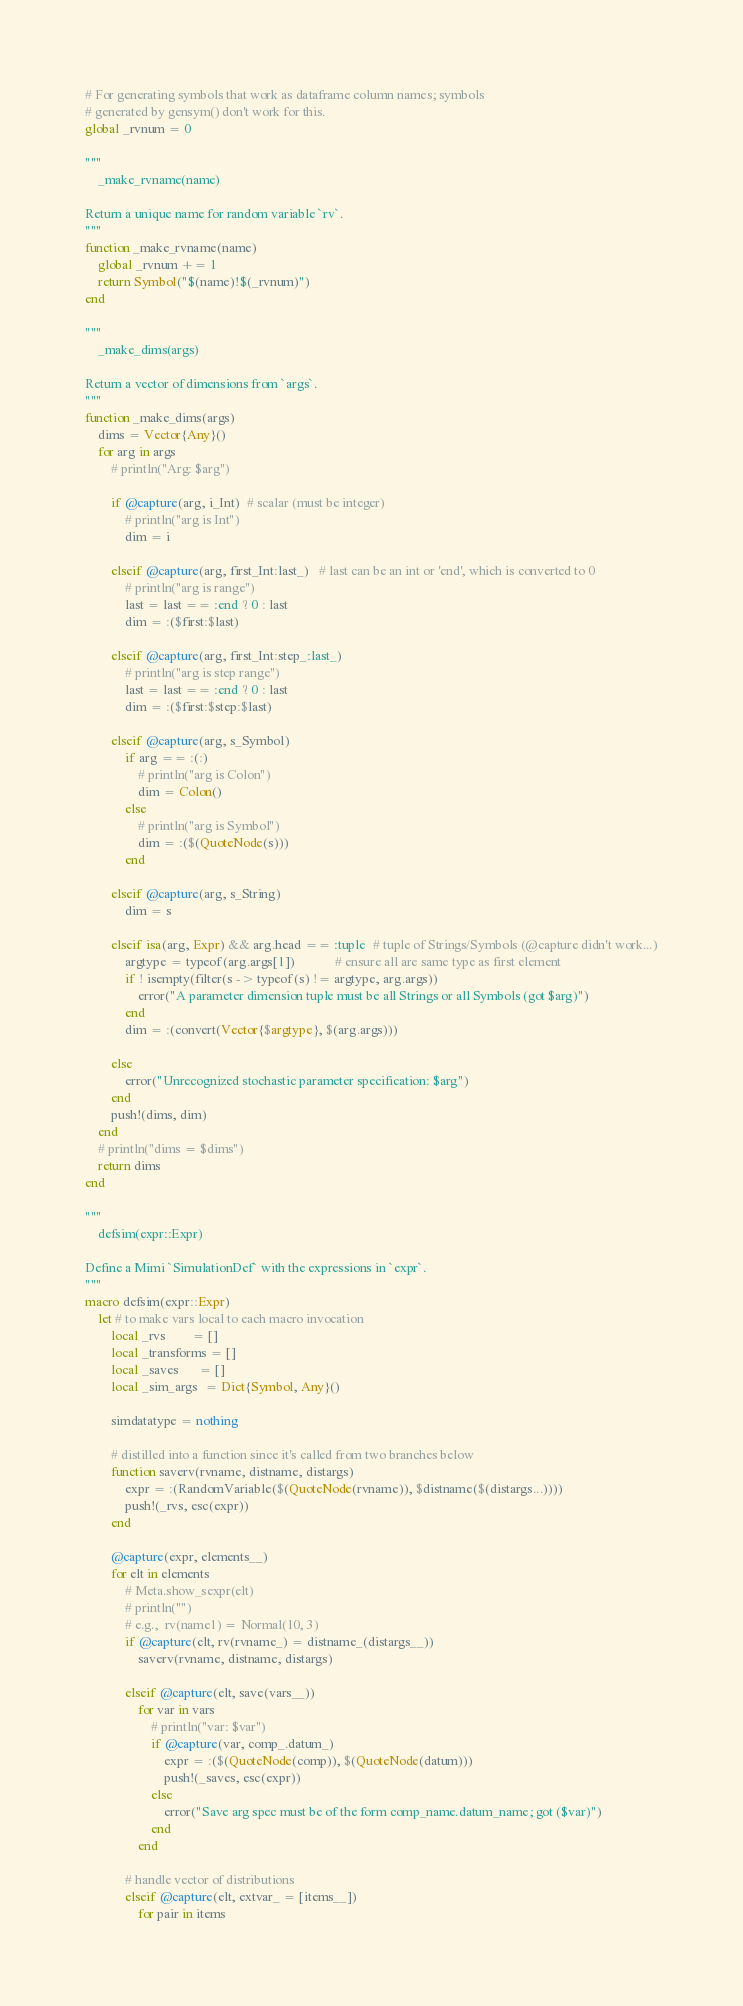<code> <loc_0><loc_0><loc_500><loc_500><_Julia_># For generating symbols that work as dataframe column names; symbols
# generated by gensym() don't work for this.
global _rvnum = 0

"""
    _make_rvname(name)

Return a unique name for random variable `rv`.
"""
function _make_rvname(name)
    global _rvnum += 1
    return Symbol("$(name)!$(_rvnum)")
end

"""
    _make_dims(args)

Return a vector of dimensions from `args`.
"""
function _make_dims(args)
    dims = Vector{Any}()
    for arg in args
        # println("Arg: $arg")

        if @capture(arg, i_Int)  # scalar (must be integer)
            # println("arg is Int")
            dim = i

        elseif @capture(arg, first_Int:last_)   # last can be an int or 'end', which is converted to 0
            # println("arg is range")
            last = last == :end ? 0 : last
            dim = :($first:$last)

        elseif @capture(arg, first_Int:step_:last_)
            # println("arg is step range")
            last = last == :end ? 0 : last
            dim = :($first:$step:$last)

        elseif @capture(arg, s_Symbol)
            if arg == :(:)
                # println("arg is Colon")
                dim = Colon()
            else
                # println("arg is Symbol")
                dim = :($(QuoteNode(s)))
            end

        elseif @capture(arg, s_String)
            dim = s

        elseif isa(arg, Expr) && arg.head == :tuple  # tuple of Strings/Symbols (@capture didn't work...)
            argtype = typeof(arg.args[1])            # ensure all are same type as first element
            if ! isempty(filter(s -> typeof(s) != argtype, arg.args))
                error("A parameter dimension tuple must be all Strings or all Symbols (got $arg)")
            end
            dim = :(convert(Vector{$argtype}, $(arg.args)))

        else
            error("Unrecognized stochastic parameter specification: $arg")
        end
        push!(dims, dim)
    end
    # println("dims = $dims")
    return dims
end

"""
    defsim(expr::Expr)

Define a Mimi `SimulationDef` with the expressions in `expr`.  
"""
macro defsim(expr::Expr)
    let # to make vars local to each macro invocation
        local _rvs        = []
        local _transforms = []
        local _saves      = []
        local _sim_args  = Dict{Symbol, Any}()

        simdatatype = nothing

        # distilled into a function since it's called from two branches below
        function saverv(rvname, distname, distargs)
            expr = :(RandomVariable($(QuoteNode(rvname)), $distname($(distargs...))))
            push!(_rvs, esc(expr))
        end

        @capture(expr, elements__)
        for elt in elements
            # Meta.show_sexpr(elt)
            # println("")
            # e.g.,  rv(name1) = Normal(10, 3)
            if @capture(elt, rv(rvname_) = distname_(distargs__))
                saverv(rvname, distname, distargs)

            elseif @capture(elt, save(vars__))
                for var in vars
                    # println("var: $var")
                    if @capture(var, comp_.datum_)
                        expr = :($(QuoteNode(comp)), $(QuoteNode(datum)))
                        push!(_saves, esc(expr))
                    else
                        error("Save arg spec must be of the form comp_name.datum_name; got ($var)")
                    end
                end

            # handle vector of distributions
            elseif @capture(elt, extvar_ = [items__])
                for pair in items</code> 